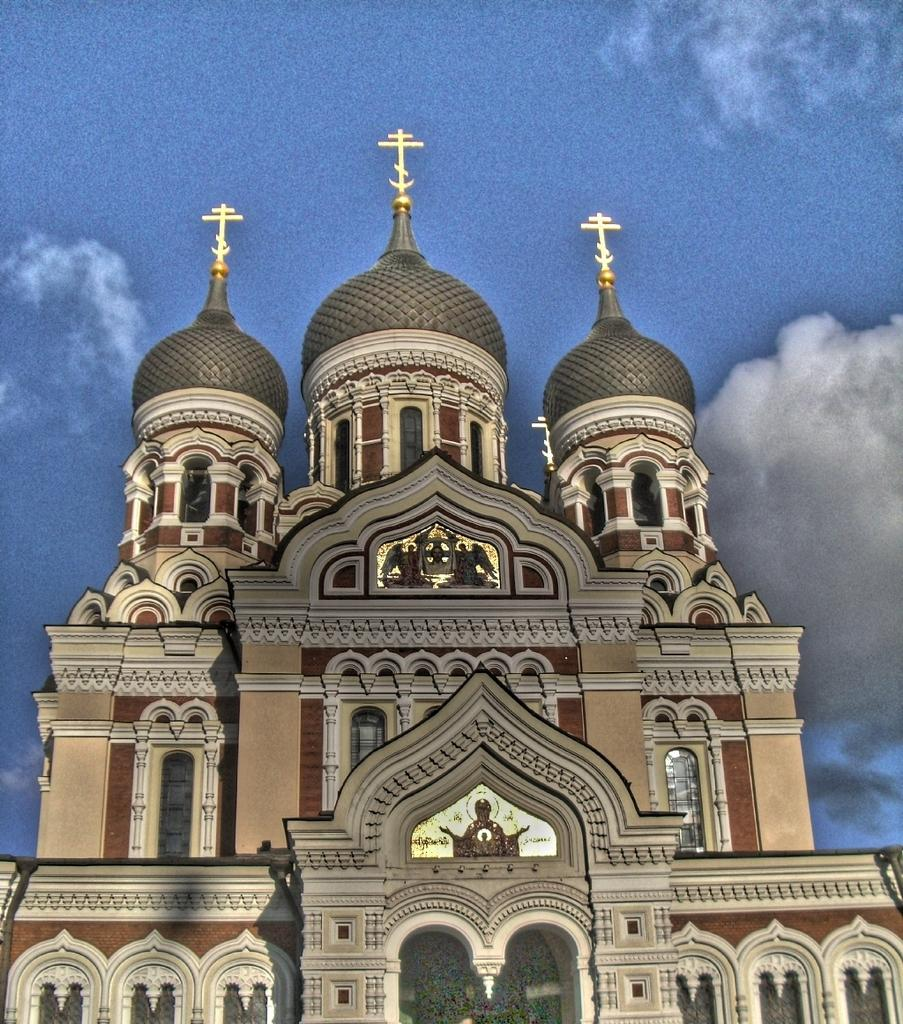What is the main structure in the image? There is a building in the image. What feature can be seen on the building? The building has windows. What can be seen in the background of the image? The sky is visible in the background of the image. What is the condition of the sky in the image? Clouds are present in the sky. How many chickens are flying in the sky in the image? There are no chickens present in the image; it only features a building with windows and a sky with clouds. 